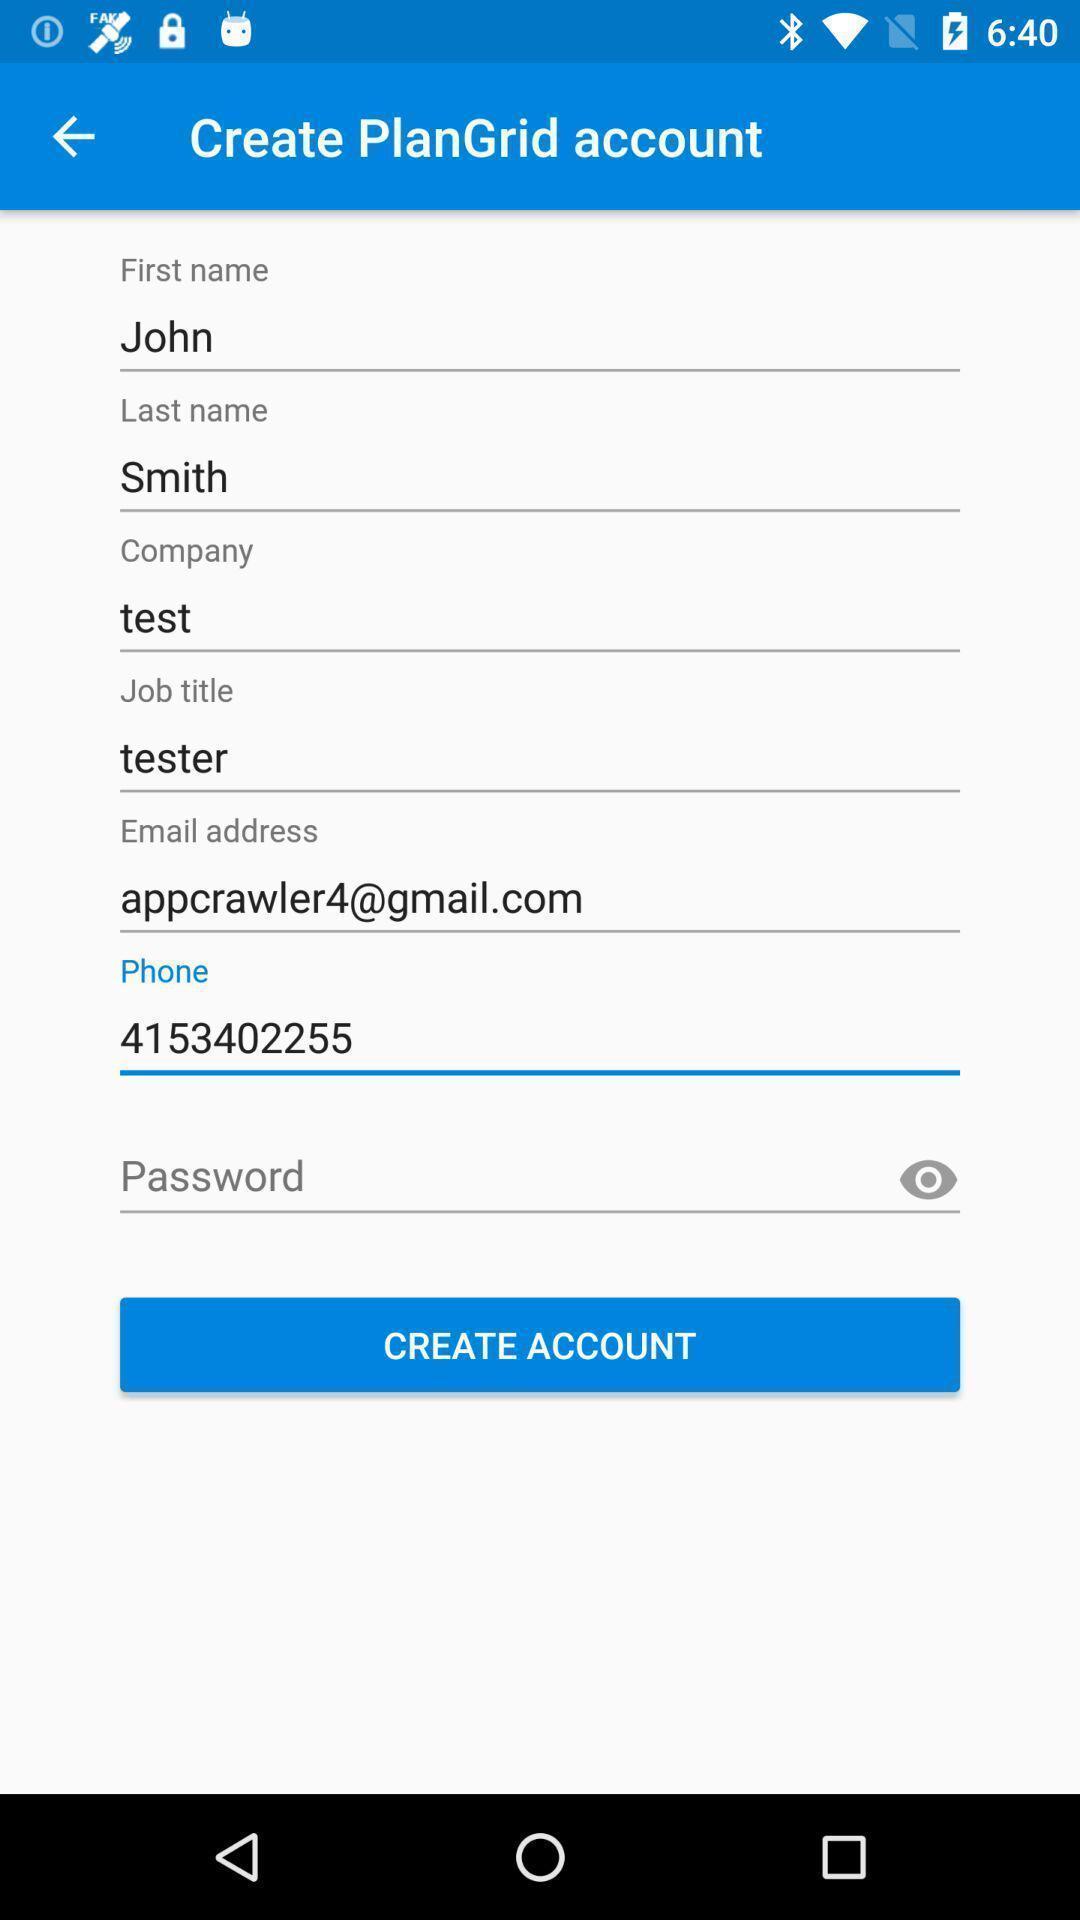Give me a summary of this screen capture. Page showing creating an account to access. 